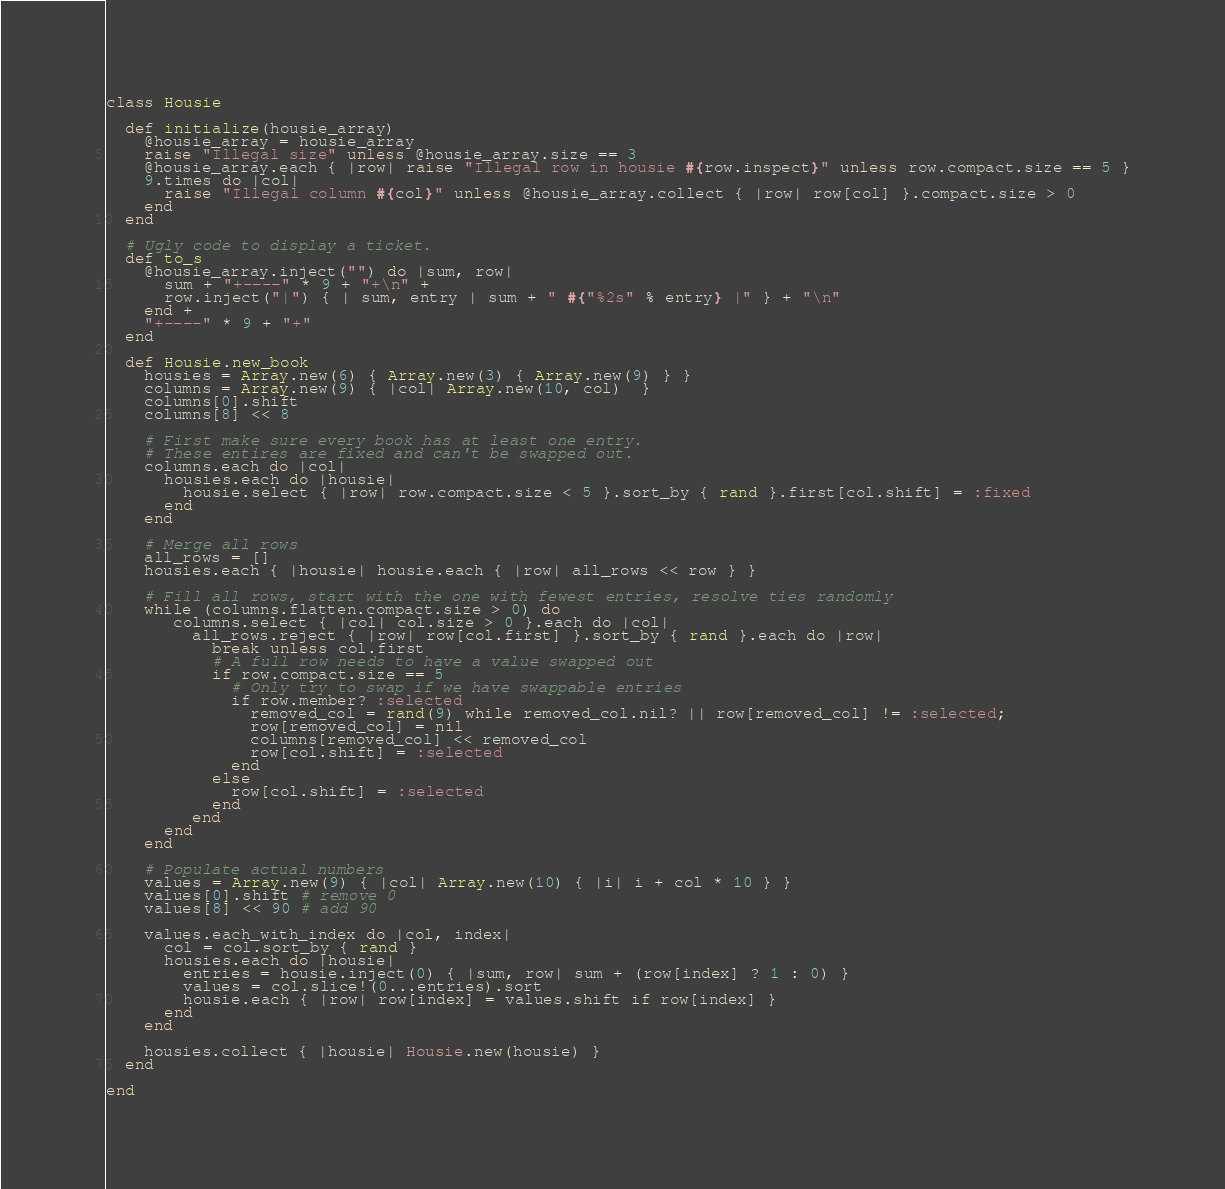<code> <loc_0><loc_0><loc_500><loc_500><_Ruby_>class Housie

  def initialize(housie_array)
    @housie_array = housie_array
    raise "Illegal size" unless @housie_array.size == 3
    @housie_array.each { |row| raise "Illegal row in housie #{row.inspect}" unless row.compact.size == 5 }
    9.times do |col|
      raise "Illegal column #{col}" unless @housie_array.collect { |row| row[col] }.compact.size > 0
    end
  end

  # Ugly code to display a ticket.
  def to_s
    @housie_array.inject("") do |sum, row|
      sum + "+----" * 9 + "+\n" +
      row.inject("|") { | sum, entry | sum + " #{"%2s" % entry} |" } + "\n"
    end +
    "+----" * 9 + "+"
  end

  def Housie.new_book
    housies = Array.new(6) { Array.new(3) { Array.new(9) } }
    columns = Array.new(9) { |col| Array.new(10, col)  }
    columns[0].shift
    columns[8] << 8

    # First make sure every book has at least one entry.
    # These entires are fixed and can't be swapped out.
    columns.each do |col|
      housies.each do |housie|
        housie.select { |row| row.compact.size < 5 }.sort_by { rand }.first[col.shift] = :fixed
      end
    end

    # Merge all rows
    all_rows = []
    housies.each { |housie| housie.each { |row| all_rows << row } }

    # Fill all rows, start with the one with fewest entries, resolve ties randomly
    while (columns.flatten.compact.size > 0) do
       columns.select { |col| col.size > 0 }.each do |col|
         all_rows.reject { |row| row[col.first] }.sort_by { rand }.each do |row|
           break unless col.first
           # A full row needs to have a value swapped out
           if row.compact.size == 5
             # Only try to swap if we have swappable entries
             if row.member? :selected
               removed_col = rand(9) while removed_col.nil? || row[removed_col] != :selected;
               row[removed_col] = nil
               columns[removed_col] << removed_col
               row[col.shift] = :selected
             end
           else
             row[col.shift] = :selected
           end
         end
      end
    end

    # Populate actual numbers
    values = Array.new(9) { |col| Array.new(10) { |i| i + col * 10 } }
    values[0].shift # remove 0
    values[8] << 90 # add 90

    values.each_with_index do |col, index|
      col = col.sort_by { rand }
      housies.each do |housie|
        entries = housie.inject(0) { |sum, row| sum + (row[index] ? 1 : 0) }
        values = col.slice!(0...entries).sort
        housie.each { |row| row[index] = values.shift if row[index] }
      end
    end

    housies.collect { |housie| Housie.new(housie) }
  end

end
</code> 